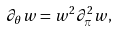Convert formula to latex. <formula><loc_0><loc_0><loc_500><loc_500>\partial _ { \theta } w = w ^ { 2 } \partial _ { \pi } ^ { 2 } w ,</formula> 